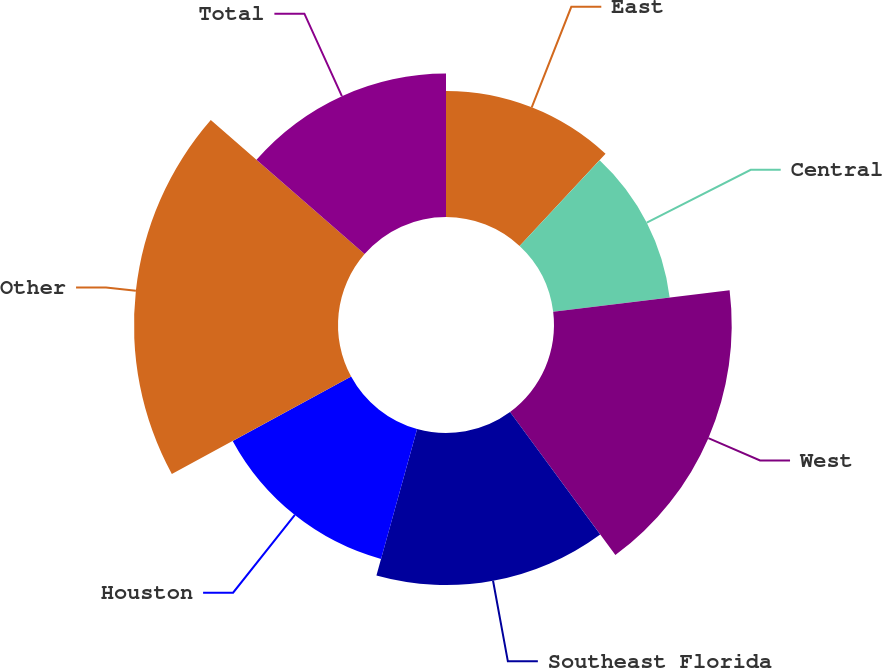Convert chart. <chart><loc_0><loc_0><loc_500><loc_500><pie_chart><fcel>East<fcel>Central<fcel>West<fcel>Southeast Florida<fcel>Houston<fcel>Other<fcel>Total<nl><fcel>11.94%<fcel>11.12%<fcel>16.84%<fcel>14.41%<fcel>12.77%<fcel>19.33%<fcel>13.59%<nl></chart> 